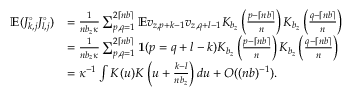<formula> <loc_0><loc_0><loc_500><loc_500>\begin{array} { r l } { \mathbb { E } ( J _ { k , j } ^ { \circ } J _ { l , j } ^ { \circ } ) } & { = \frac { 1 } { n b _ { z } \kappa } \sum _ { p , q = 1 } ^ { 2 \lceil n b \rceil } \mathbb { E } v _ { z , p + k - 1 } v _ { z , q + l - 1 } K _ { b _ { z } } \left ( \frac { p - \lceil n b \rceil } { n } \right ) K _ { b _ { z } } \left ( \frac { q - \lceil n b \rceil } { n } \right ) } \\ & { = \frac { 1 } { n b _ { z } \kappa } \sum _ { p , q = 1 } ^ { 2 \lceil n b \rceil } \mathbf 1 ( p = q + l - k ) K _ { b _ { z } } \left ( \frac { p - \lceil n b \rceil } { n } \right ) K _ { b _ { z } } \left ( \frac { q - \lceil n b \rceil } { n } \right ) } \\ & { = \kappa ^ { - 1 } \int K ( u ) K \left ( u + \frac { k - l } { n b _ { z } } \right ) d u + O ( ( n b ) ^ { - 1 } ) . } \end{array}</formula> 